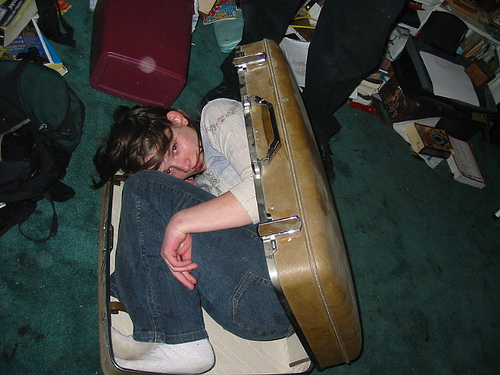<image>Will the girl eat bean burritos before closing the suitcase? It is unknown if the girl will eat bean burritos before closing the suitcase. Will the girl eat bean burritos before closing the suitcase? It is unknown if the girl will eat bean burritos before closing the suitcase. 